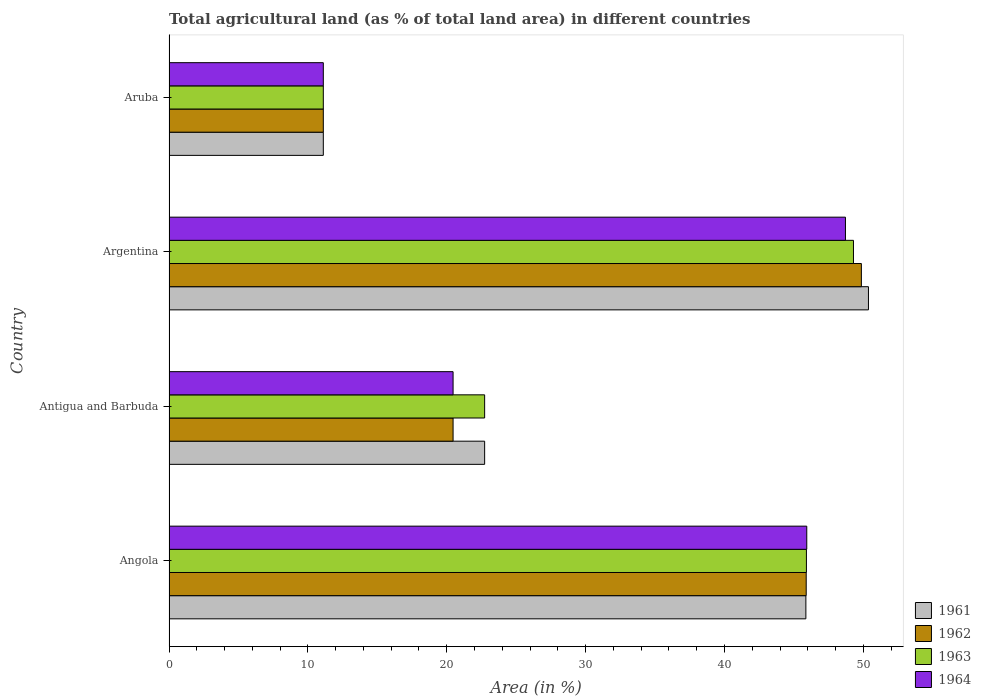How many groups of bars are there?
Your answer should be compact. 4. Are the number of bars per tick equal to the number of legend labels?
Your answer should be compact. Yes. Are the number of bars on each tick of the Y-axis equal?
Provide a short and direct response. Yes. How many bars are there on the 3rd tick from the top?
Your response must be concise. 4. What is the label of the 2nd group of bars from the top?
Offer a very short reply. Argentina. In how many cases, is the number of bars for a given country not equal to the number of legend labels?
Provide a short and direct response. 0. What is the percentage of agricultural land in 1963 in Antigua and Barbuda?
Make the answer very short. 22.73. Across all countries, what is the maximum percentage of agricultural land in 1962?
Keep it short and to the point. 49.85. Across all countries, what is the minimum percentage of agricultural land in 1963?
Make the answer very short. 11.11. In which country was the percentage of agricultural land in 1961 maximum?
Ensure brevity in your answer.  Argentina. In which country was the percentage of agricultural land in 1963 minimum?
Ensure brevity in your answer.  Aruba. What is the total percentage of agricultural land in 1961 in the graph?
Your answer should be compact. 130.06. What is the difference between the percentage of agricultural land in 1962 in Angola and that in Antigua and Barbuda?
Offer a terse response. 25.43. What is the difference between the percentage of agricultural land in 1961 in Angola and the percentage of agricultural land in 1963 in Aruba?
Your answer should be very brief. 34.75. What is the average percentage of agricultural land in 1961 per country?
Offer a very short reply. 32.51. What is the difference between the percentage of agricultural land in 1963 and percentage of agricultural land in 1964 in Antigua and Barbuda?
Give a very brief answer. 2.27. In how many countries, is the percentage of agricultural land in 1963 greater than 22 %?
Offer a terse response. 3. What is the ratio of the percentage of agricultural land in 1963 in Angola to that in Antigua and Barbuda?
Your answer should be compact. 2.02. What is the difference between the highest and the second highest percentage of agricultural land in 1961?
Offer a very short reply. 4.51. What is the difference between the highest and the lowest percentage of agricultural land in 1964?
Ensure brevity in your answer.  37.6. In how many countries, is the percentage of agricultural land in 1963 greater than the average percentage of agricultural land in 1963 taken over all countries?
Offer a terse response. 2. Is the sum of the percentage of agricultural land in 1964 in Antigua and Barbuda and Argentina greater than the maximum percentage of agricultural land in 1962 across all countries?
Your answer should be very brief. Yes. Is it the case that in every country, the sum of the percentage of agricultural land in 1963 and percentage of agricultural land in 1961 is greater than the sum of percentage of agricultural land in 1962 and percentage of agricultural land in 1964?
Make the answer very short. No. What does the 4th bar from the bottom in Angola represents?
Offer a terse response. 1964. What is the difference between two consecutive major ticks on the X-axis?
Offer a terse response. 10. Are the values on the major ticks of X-axis written in scientific E-notation?
Make the answer very short. No. Does the graph contain grids?
Your response must be concise. No. Where does the legend appear in the graph?
Keep it short and to the point. Bottom right. What is the title of the graph?
Your answer should be compact. Total agricultural land (as % of total land area) in different countries. What is the label or title of the X-axis?
Offer a very short reply. Area (in %). What is the label or title of the Y-axis?
Provide a short and direct response. Country. What is the Area (in %) in 1961 in Angola?
Your answer should be very brief. 45.86. What is the Area (in %) in 1962 in Angola?
Provide a short and direct response. 45.88. What is the Area (in %) of 1963 in Angola?
Keep it short and to the point. 45.9. What is the Area (in %) of 1964 in Angola?
Your answer should be very brief. 45.92. What is the Area (in %) in 1961 in Antigua and Barbuda?
Offer a terse response. 22.73. What is the Area (in %) of 1962 in Antigua and Barbuda?
Your answer should be compact. 20.45. What is the Area (in %) in 1963 in Antigua and Barbuda?
Give a very brief answer. 22.73. What is the Area (in %) in 1964 in Antigua and Barbuda?
Make the answer very short. 20.45. What is the Area (in %) of 1961 in Argentina?
Your answer should be very brief. 50.36. What is the Area (in %) of 1962 in Argentina?
Make the answer very short. 49.85. What is the Area (in %) in 1963 in Argentina?
Give a very brief answer. 49.28. What is the Area (in %) in 1964 in Argentina?
Give a very brief answer. 48.71. What is the Area (in %) of 1961 in Aruba?
Keep it short and to the point. 11.11. What is the Area (in %) of 1962 in Aruba?
Offer a very short reply. 11.11. What is the Area (in %) in 1963 in Aruba?
Your answer should be very brief. 11.11. What is the Area (in %) of 1964 in Aruba?
Give a very brief answer. 11.11. Across all countries, what is the maximum Area (in %) of 1961?
Keep it short and to the point. 50.36. Across all countries, what is the maximum Area (in %) of 1962?
Ensure brevity in your answer.  49.85. Across all countries, what is the maximum Area (in %) of 1963?
Keep it short and to the point. 49.28. Across all countries, what is the maximum Area (in %) in 1964?
Your answer should be compact. 48.71. Across all countries, what is the minimum Area (in %) in 1961?
Your response must be concise. 11.11. Across all countries, what is the minimum Area (in %) in 1962?
Offer a very short reply. 11.11. Across all countries, what is the minimum Area (in %) in 1963?
Your answer should be very brief. 11.11. Across all countries, what is the minimum Area (in %) in 1964?
Offer a very short reply. 11.11. What is the total Area (in %) in 1961 in the graph?
Your answer should be very brief. 130.06. What is the total Area (in %) in 1962 in the graph?
Provide a short and direct response. 127.3. What is the total Area (in %) in 1963 in the graph?
Your answer should be compact. 129.02. What is the total Area (in %) in 1964 in the graph?
Provide a succinct answer. 126.19. What is the difference between the Area (in %) in 1961 in Angola and that in Antigua and Barbuda?
Your answer should be compact. 23.13. What is the difference between the Area (in %) of 1962 in Angola and that in Antigua and Barbuda?
Offer a very short reply. 25.43. What is the difference between the Area (in %) in 1963 in Angola and that in Antigua and Barbuda?
Your response must be concise. 23.17. What is the difference between the Area (in %) in 1964 in Angola and that in Antigua and Barbuda?
Your answer should be compact. 25.47. What is the difference between the Area (in %) in 1961 in Angola and that in Argentina?
Make the answer very short. -4.51. What is the difference between the Area (in %) of 1962 in Angola and that in Argentina?
Your answer should be compact. -3.97. What is the difference between the Area (in %) in 1963 in Angola and that in Argentina?
Your answer should be very brief. -3.39. What is the difference between the Area (in %) in 1964 in Angola and that in Argentina?
Offer a very short reply. -2.79. What is the difference between the Area (in %) in 1961 in Angola and that in Aruba?
Your answer should be very brief. 34.75. What is the difference between the Area (in %) of 1962 in Angola and that in Aruba?
Provide a short and direct response. 34.77. What is the difference between the Area (in %) of 1963 in Angola and that in Aruba?
Give a very brief answer. 34.79. What is the difference between the Area (in %) of 1964 in Angola and that in Aruba?
Offer a very short reply. 34.81. What is the difference between the Area (in %) in 1961 in Antigua and Barbuda and that in Argentina?
Your response must be concise. -27.64. What is the difference between the Area (in %) of 1962 in Antigua and Barbuda and that in Argentina?
Provide a short and direct response. -29.4. What is the difference between the Area (in %) in 1963 in Antigua and Barbuda and that in Argentina?
Offer a very short reply. -26.56. What is the difference between the Area (in %) in 1964 in Antigua and Barbuda and that in Argentina?
Make the answer very short. -28.25. What is the difference between the Area (in %) of 1961 in Antigua and Barbuda and that in Aruba?
Give a very brief answer. 11.62. What is the difference between the Area (in %) in 1962 in Antigua and Barbuda and that in Aruba?
Your answer should be very brief. 9.34. What is the difference between the Area (in %) of 1963 in Antigua and Barbuda and that in Aruba?
Offer a terse response. 11.62. What is the difference between the Area (in %) of 1964 in Antigua and Barbuda and that in Aruba?
Keep it short and to the point. 9.34. What is the difference between the Area (in %) in 1961 in Argentina and that in Aruba?
Your response must be concise. 39.25. What is the difference between the Area (in %) in 1962 in Argentina and that in Aruba?
Give a very brief answer. 38.74. What is the difference between the Area (in %) of 1963 in Argentina and that in Aruba?
Provide a short and direct response. 38.17. What is the difference between the Area (in %) in 1964 in Argentina and that in Aruba?
Keep it short and to the point. 37.6. What is the difference between the Area (in %) in 1961 in Angola and the Area (in %) in 1962 in Antigua and Barbuda?
Your response must be concise. 25.4. What is the difference between the Area (in %) of 1961 in Angola and the Area (in %) of 1963 in Antigua and Barbuda?
Offer a very short reply. 23.13. What is the difference between the Area (in %) of 1961 in Angola and the Area (in %) of 1964 in Antigua and Barbuda?
Your answer should be very brief. 25.4. What is the difference between the Area (in %) in 1962 in Angola and the Area (in %) in 1963 in Antigua and Barbuda?
Provide a short and direct response. 23.15. What is the difference between the Area (in %) of 1962 in Angola and the Area (in %) of 1964 in Antigua and Barbuda?
Your response must be concise. 25.43. What is the difference between the Area (in %) in 1963 in Angola and the Area (in %) in 1964 in Antigua and Barbuda?
Make the answer very short. 25.44. What is the difference between the Area (in %) in 1961 in Angola and the Area (in %) in 1962 in Argentina?
Offer a very short reply. -4. What is the difference between the Area (in %) of 1961 in Angola and the Area (in %) of 1963 in Argentina?
Your answer should be very brief. -3.43. What is the difference between the Area (in %) of 1961 in Angola and the Area (in %) of 1964 in Argentina?
Your response must be concise. -2.85. What is the difference between the Area (in %) in 1962 in Angola and the Area (in %) in 1963 in Argentina?
Offer a terse response. -3.4. What is the difference between the Area (in %) in 1962 in Angola and the Area (in %) in 1964 in Argentina?
Keep it short and to the point. -2.83. What is the difference between the Area (in %) in 1963 in Angola and the Area (in %) in 1964 in Argentina?
Your answer should be very brief. -2.81. What is the difference between the Area (in %) of 1961 in Angola and the Area (in %) of 1962 in Aruba?
Offer a terse response. 34.75. What is the difference between the Area (in %) of 1961 in Angola and the Area (in %) of 1963 in Aruba?
Offer a very short reply. 34.75. What is the difference between the Area (in %) of 1961 in Angola and the Area (in %) of 1964 in Aruba?
Give a very brief answer. 34.75. What is the difference between the Area (in %) of 1962 in Angola and the Area (in %) of 1963 in Aruba?
Offer a terse response. 34.77. What is the difference between the Area (in %) in 1962 in Angola and the Area (in %) in 1964 in Aruba?
Ensure brevity in your answer.  34.77. What is the difference between the Area (in %) of 1963 in Angola and the Area (in %) of 1964 in Aruba?
Make the answer very short. 34.79. What is the difference between the Area (in %) in 1961 in Antigua and Barbuda and the Area (in %) in 1962 in Argentina?
Your answer should be very brief. -27.13. What is the difference between the Area (in %) in 1961 in Antigua and Barbuda and the Area (in %) in 1963 in Argentina?
Provide a succinct answer. -26.56. What is the difference between the Area (in %) of 1961 in Antigua and Barbuda and the Area (in %) of 1964 in Argentina?
Make the answer very short. -25.98. What is the difference between the Area (in %) in 1962 in Antigua and Barbuda and the Area (in %) in 1963 in Argentina?
Keep it short and to the point. -28.83. What is the difference between the Area (in %) in 1962 in Antigua and Barbuda and the Area (in %) in 1964 in Argentina?
Your response must be concise. -28.25. What is the difference between the Area (in %) of 1963 in Antigua and Barbuda and the Area (in %) of 1964 in Argentina?
Offer a terse response. -25.98. What is the difference between the Area (in %) in 1961 in Antigua and Barbuda and the Area (in %) in 1962 in Aruba?
Offer a very short reply. 11.62. What is the difference between the Area (in %) in 1961 in Antigua and Barbuda and the Area (in %) in 1963 in Aruba?
Ensure brevity in your answer.  11.62. What is the difference between the Area (in %) of 1961 in Antigua and Barbuda and the Area (in %) of 1964 in Aruba?
Provide a succinct answer. 11.62. What is the difference between the Area (in %) in 1962 in Antigua and Barbuda and the Area (in %) in 1963 in Aruba?
Your answer should be compact. 9.34. What is the difference between the Area (in %) in 1962 in Antigua and Barbuda and the Area (in %) in 1964 in Aruba?
Keep it short and to the point. 9.34. What is the difference between the Area (in %) of 1963 in Antigua and Barbuda and the Area (in %) of 1964 in Aruba?
Keep it short and to the point. 11.62. What is the difference between the Area (in %) of 1961 in Argentina and the Area (in %) of 1962 in Aruba?
Give a very brief answer. 39.25. What is the difference between the Area (in %) of 1961 in Argentina and the Area (in %) of 1963 in Aruba?
Provide a succinct answer. 39.25. What is the difference between the Area (in %) in 1961 in Argentina and the Area (in %) in 1964 in Aruba?
Your answer should be compact. 39.25. What is the difference between the Area (in %) in 1962 in Argentina and the Area (in %) in 1963 in Aruba?
Offer a very short reply. 38.74. What is the difference between the Area (in %) in 1962 in Argentina and the Area (in %) in 1964 in Aruba?
Provide a succinct answer. 38.74. What is the difference between the Area (in %) in 1963 in Argentina and the Area (in %) in 1964 in Aruba?
Your response must be concise. 38.17. What is the average Area (in %) of 1961 per country?
Provide a short and direct response. 32.51. What is the average Area (in %) of 1962 per country?
Your response must be concise. 31.83. What is the average Area (in %) in 1963 per country?
Your response must be concise. 32.25. What is the average Area (in %) of 1964 per country?
Your answer should be compact. 31.55. What is the difference between the Area (in %) in 1961 and Area (in %) in 1962 in Angola?
Give a very brief answer. -0.02. What is the difference between the Area (in %) of 1961 and Area (in %) of 1963 in Angola?
Make the answer very short. -0.04. What is the difference between the Area (in %) in 1961 and Area (in %) in 1964 in Angola?
Give a very brief answer. -0.06. What is the difference between the Area (in %) in 1962 and Area (in %) in 1963 in Angola?
Give a very brief answer. -0.02. What is the difference between the Area (in %) of 1962 and Area (in %) of 1964 in Angola?
Make the answer very short. -0.04. What is the difference between the Area (in %) of 1963 and Area (in %) of 1964 in Angola?
Your answer should be compact. -0.02. What is the difference between the Area (in %) in 1961 and Area (in %) in 1962 in Antigua and Barbuda?
Provide a succinct answer. 2.27. What is the difference between the Area (in %) of 1961 and Area (in %) of 1964 in Antigua and Barbuda?
Ensure brevity in your answer.  2.27. What is the difference between the Area (in %) in 1962 and Area (in %) in 1963 in Antigua and Barbuda?
Keep it short and to the point. -2.27. What is the difference between the Area (in %) in 1963 and Area (in %) in 1964 in Antigua and Barbuda?
Offer a terse response. 2.27. What is the difference between the Area (in %) in 1961 and Area (in %) in 1962 in Argentina?
Your answer should be very brief. 0.51. What is the difference between the Area (in %) in 1961 and Area (in %) in 1963 in Argentina?
Keep it short and to the point. 1.08. What is the difference between the Area (in %) in 1961 and Area (in %) in 1964 in Argentina?
Provide a succinct answer. 1.66. What is the difference between the Area (in %) in 1962 and Area (in %) in 1963 in Argentina?
Offer a very short reply. 0.57. What is the difference between the Area (in %) of 1962 and Area (in %) of 1964 in Argentina?
Your response must be concise. 1.15. What is the difference between the Area (in %) in 1963 and Area (in %) in 1964 in Argentina?
Your answer should be compact. 0.58. What is the difference between the Area (in %) in 1961 and Area (in %) in 1964 in Aruba?
Your response must be concise. 0. What is the difference between the Area (in %) in 1962 and Area (in %) in 1963 in Aruba?
Your answer should be very brief. 0. What is the difference between the Area (in %) of 1963 and Area (in %) of 1964 in Aruba?
Offer a very short reply. 0. What is the ratio of the Area (in %) of 1961 in Angola to that in Antigua and Barbuda?
Your answer should be very brief. 2.02. What is the ratio of the Area (in %) in 1962 in Angola to that in Antigua and Barbuda?
Provide a short and direct response. 2.24. What is the ratio of the Area (in %) in 1963 in Angola to that in Antigua and Barbuda?
Keep it short and to the point. 2.02. What is the ratio of the Area (in %) of 1964 in Angola to that in Antigua and Barbuda?
Your answer should be compact. 2.25. What is the ratio of the Area (in %) of 1961 in Angola to that in Argentina?
Offer a very short reply. 0.91. What is the ratio of the Area (in %) in 1962 in Angola to that in Argentina?
Provide a succinct answer. 0.92. What is the ratio of the Area (in %) of 1963 in Angola to that in Argentina?
Provide a short and direct response. 0.93. What is the ratio of the Area (in %) of 1964 in Angola to that in Argentina?
Make the answer very short. 0.94. What is the ratio of the Area (in %) in 1961 in Angola to that in Aruba?
Provide a succinct answer. 4.13. What is the ratio of the Area (in %) in 1962 in Angola to that in Aruba?
Make the answer very short. 4.13. What is the ratio of the Area (in %) of 1963 in Angola to that in Aruba?
Give a very brief answer. 4.13. What is the ratio of the Area (in %) in 1964 in Angola to that in Aruba?
Ensure brevity in your answer.  4.13. What is the ratio of the Area (in %) in 1961 in Antigua and Barbuda to that in Argentina?
Your answer should be very brief. 0.45. What is the ratio of the Area (in %) of 1962 in Antigua and Barbuda to that in Argentina?
Offer a very short reply. 0.41. What is the ratio of the Area (in %) in 1963 in Antigua and Barbuda to that in Argentina?
Your answer should be very brief. 0.46. What is the ratio of the Area (in %) in 1964 in Antigua and Barbuda to that in Argentina?
Your answer should be very brief. 0.42. What is the ratio of the Area (in %) of 1961 in Antigua and Barbuda to that in Aruba?
Provide a short and direct response. 2.05. What is the ratio of the Area (in %) in 1962 in Antigua and Barbuda to that in Aruba?
Ensure brevity in your answer.  1.84. What is the ratio of the Area (in %) of 1963 in Antigua and Barbuda to that in Aruba?
Your response must be concise. 2.05. What is the ratio of the Area (in %) in 1964 in Antigua and Barbuda to that in Aruba?
Provide a short and direct response. 1.84. What is the ratio of the Area (in %) of 1961 in Argentina to that in Aruba?
Provide a short and direct response. 4.53. What is the ratio of the Area (in %) in 1962 in Argentina to that in Aruba?
Your answer should be compact. 4.49. What is the ratio of the Area (in %) of 1963 in Argentina to that in Aruba?
Keep it short and to the point. 4.44. What is the ratio of the Area (in %) in 1964 in Argentina to that in Aruba?
Your response must be concise. 4.38. What is the difference between the highest and the second highest Area (in %) in 1961?
Give a very brief answer. 4.51. What is the difference between the highest and the second highest Area (in %) in 1962?
Ensure brevity in your answer.  3.97. What is the difference between the highest and the second highest Area (in %) of 1963?
Your response must be concise. 3.39. What is the difference between the highest and the second highest Area (in %) of 1964?
Make the answer very short. 2.79. What is the difference between the highest and the lowest Area (in %) in 1961?
Keep it short and to the point. 39.25. What is the difference between the highest and the lowest Area (in %) in 1962?
Make the answer very short. 38.74. What is the difference between the highest and the lowest Area (in %) of 1963?
Ensure brevity in your answer.  38.17. What is the difference between the highest and the lowest Area (in %) of 1964?
Provide a short and direct response. 37.6. 